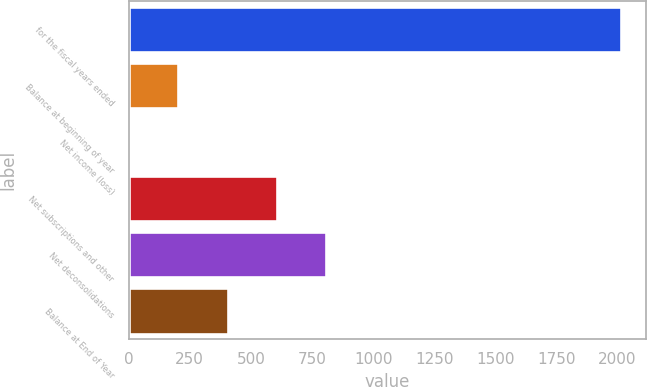Convert chart. <chart><loc_0><loc_0><loc_500><loc_500><bar_chart><fcel>for the fiscal years ended<fcel>Balance at beginning of year<fcel>Net income (loss)<fcel>Net subscriptions and other<fcel>Net deconsolidations<fcel>Balance at End of Year<nl><fcel>2016<fcel>203.04<fcel>1.6<fcel>605.92<fcel>807.36<fcel>404.48<nl></chart> 